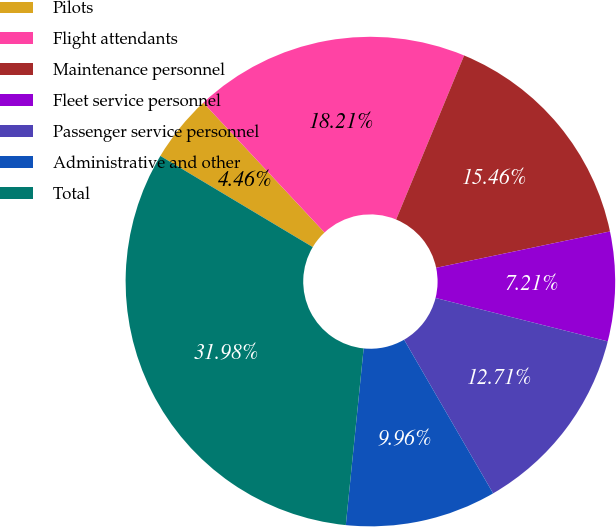<chart> <loc_0><loc_0><loc_500><loc_500><pie_chart><fcel>Pilots<fcel>Flight attendants<fcel>Maintenance personnel<fcel>Fleet service personnel<fcel>Passenger service personnel<fcel>Administrative and other<fcel>Total<nl><fcel>4.46%<fcel>18.21%<fcel>15.46%<fcel>7.21%<fcel>12.71%<fcel>9.96%<fcel>31.97%<nl></chart> 